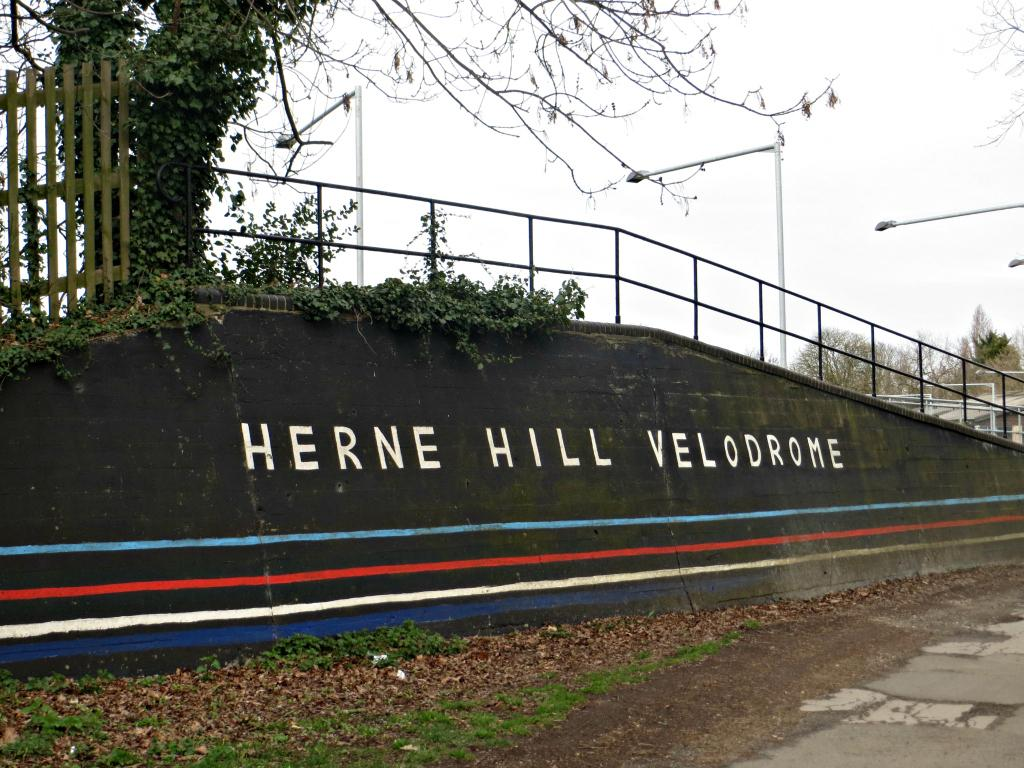<image>
Give a short and clear explanation of the subsequent image. Words on a hill side annouce Herne Hill Velodrome. 